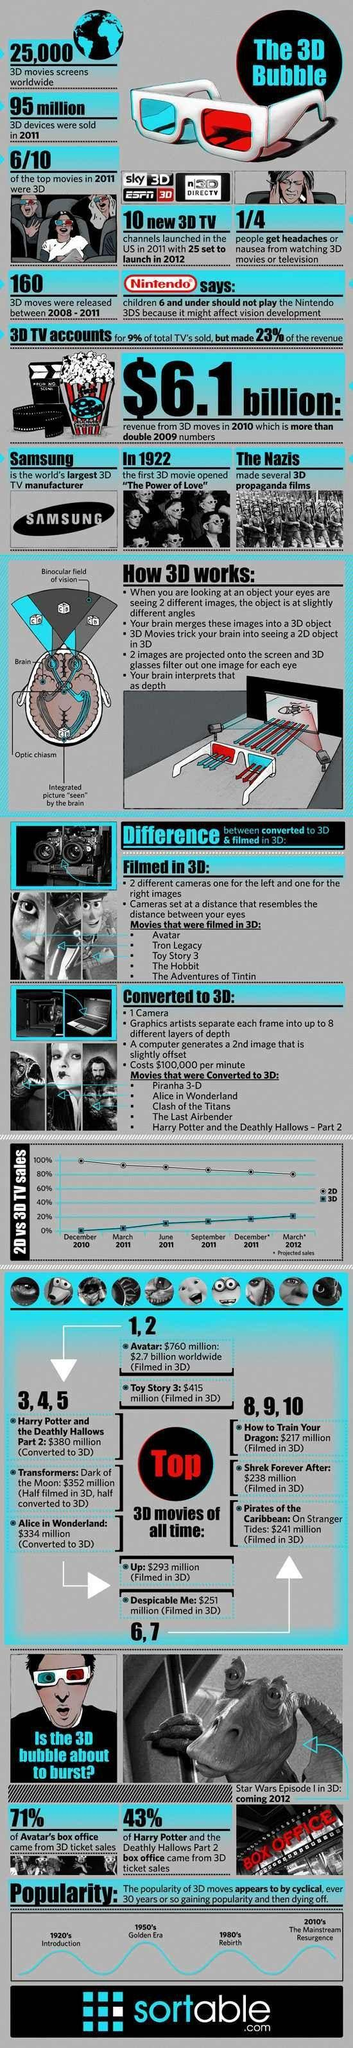How many movies listed in the info graphic are filmed in 3D?
Answer the question with a short phrase. 5 In which year highest no of 2D TVs were sold? December 2010 What percentage of amount movie Avatar gained from 3D ticket sales? 71% In which year 3D TV sale was the least? December 2010 How many top movies released in 2011 were not 3D? 4 How many people won't get any health problems from watching 3D movies or television? 3 In which year more no of 3D TVs were sold? March 2012 How much was the gain of the movie "How to Train your Dragon"? $217 million Which is the second top 3D movie? Toy Story 3 How many movies listed were converted into 3D? 5 